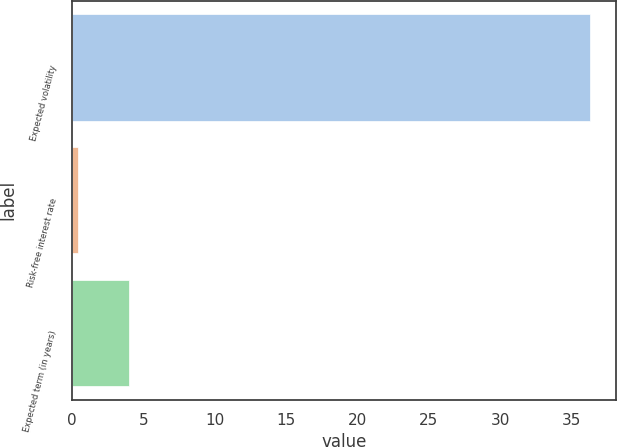<chart> <loc_0><loc_0><loc_500><loc_500><bar_chart><fcel>Expected volatility<fcel>Risk-free interest rate<fcel>Expected term (in years)<nl><fcel>36.3<fcel>0.42<fcel>4.01<nl></chart> 